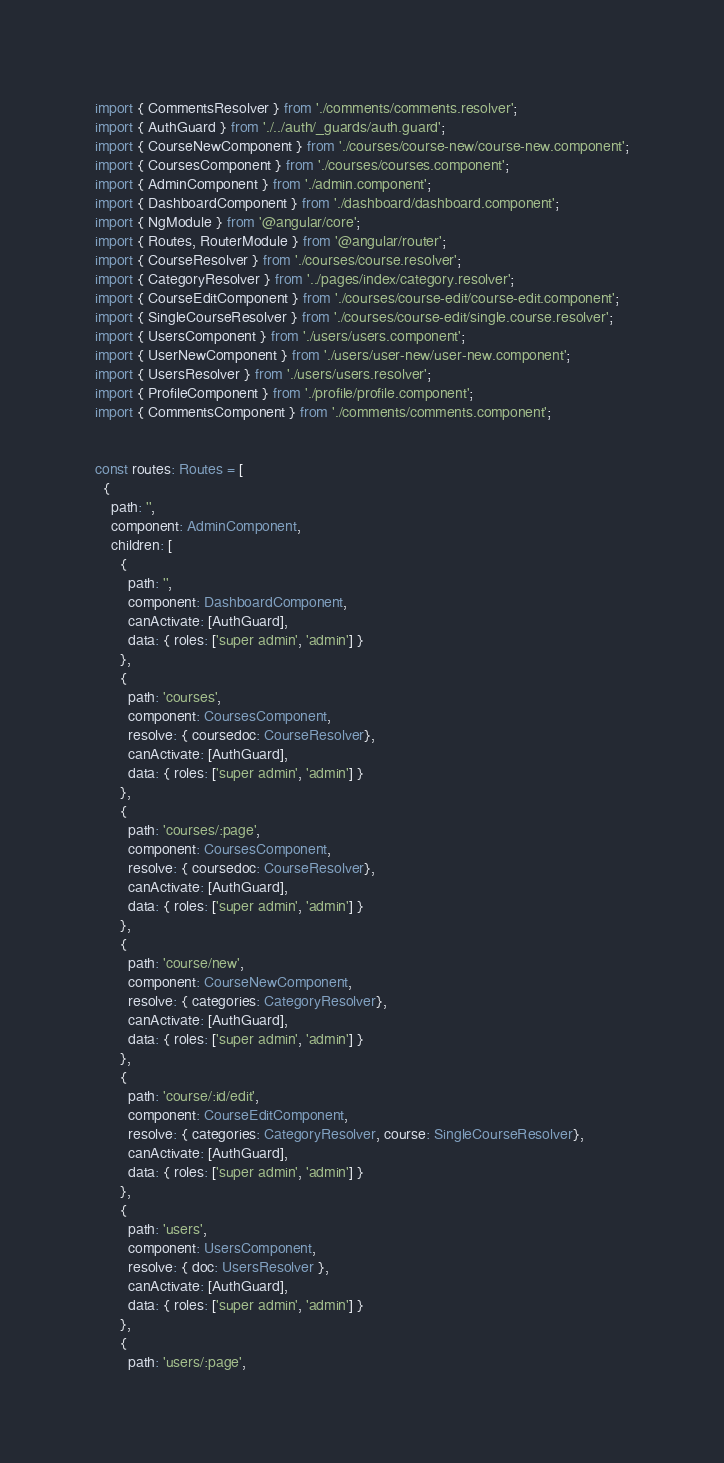Convert code to text. <code><loc_0><loc_0><loc_500><loc_500><_TypeScript_>import { CommentsResolver } from './comments/comments.resolver';
import { AuthGuard } from './../auth/_guards/auth.guard';
import { CourseNewComponent } from './courses/course-new/course-new.component';
import { CoursesComponent } from './courses/courses.component';
import { AdminComponent } from './admin.component';
import { DashboardComponent } from './dashboard/dashboard.component';
import { NgModule } from '@angular/core';
import { Routes, RouterModule } from '@angular/router';
import { CourseResolver } from './courses/course.resolver';
import { CategoryResolver } from '../pages/index/category.resolver';
import { CourseEditComponent } from './courses/course-edit/course-edit.component';
import { SingleCourseResolver } from './courses/course-edit/single.course.resolver';
import { UsersComponent } from './users/users.component';
import { UserNewComponent } from './users/user-new/user-new.component';
import { UsersResolver } from './users/users.resolver';
import { ProfileComponent } from './profile/profile.component';
import { CommentsComponent } from './comments/comments.component';


const routes: Routes = [
  {
    path: '',
    component: AdminComponent,
    children: [
      {
        path: '',
        component: DashboardComponent,
        canActivate: [AuthGuard],
        data: { roles: ['super admin', 'admin'] } 
      },
      {
        path: 'courses',
        component: CoursesComponent,
        resolve: { coursedoc: CourseResolver},
        canActivate: [AuthGuard],
        data: { roles: ['super admin', 'admin'] } 
      },
      {
        path: 'courses/:page',
        component: CoursesComponent,
        resolve: { coursedoc: CourseResolver},
        canActivate: [AuthGuard],
        data: { roles: ['super admin', 'admin'] } 
      },
      {
        path: 'course/new',
        component: CourseNewComponent,
        resolve: { categories: CategoryResolver},
        canActivate: [AuthGuard],
        data: { roles: ['super admin', 'admin'] } 
      },
      {
        path: 'course/:id/edit',
        component: CourseEditComponent,
        resolve: { categories: CategoryResolver, course: SingleCourseResolver},
        canActivate: [AuthGuard],
        data: { roles: ['super admin', 'admin'] } 
      },
      {
        path: 'users',
        component: UsersComponent,
        resolve: { doc: UsersResolver },
        canActivate: [AuthGuard],
        data: { roles: ['super admin', 'admin'] } 
      },
      {
        path: 'users/:page',</code> 